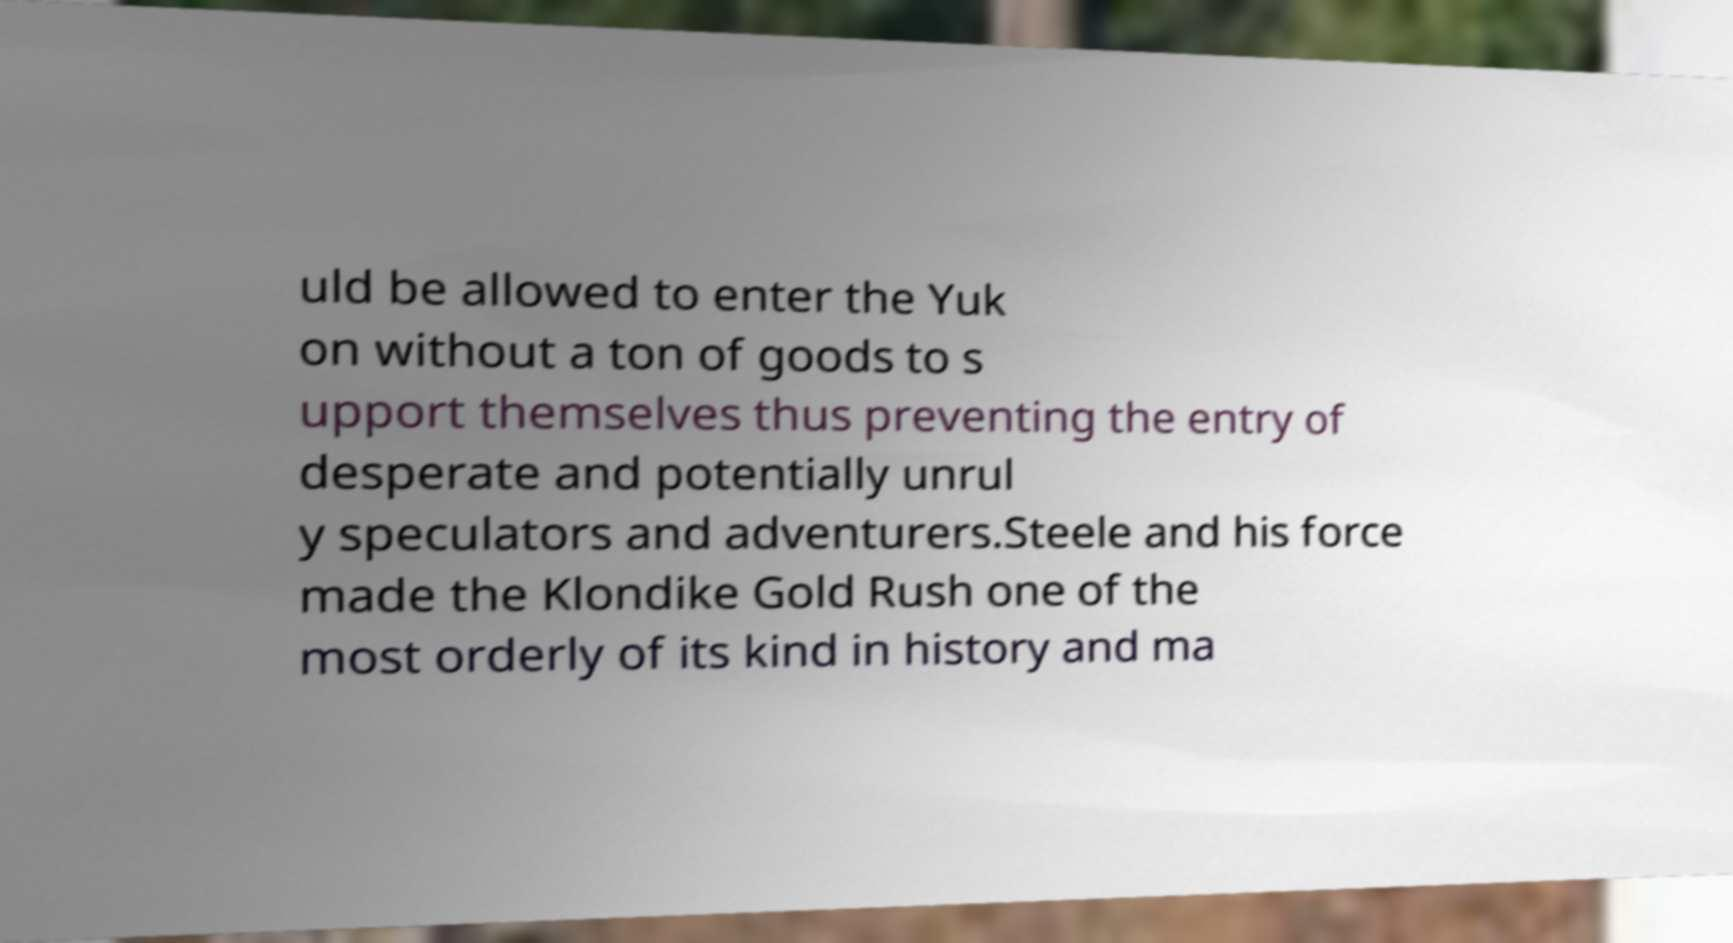Could you assist in decoding the text presented in this image and type it out clearly? uld be allowed to enter the Yuk on without a ton of goods to s upport themselves thus preventing the entry of desperate and potentially unrul y speculators and adventurers.Steele and his force made the Klondike Gold Rush one of the most orderly of its kind in history and ma 